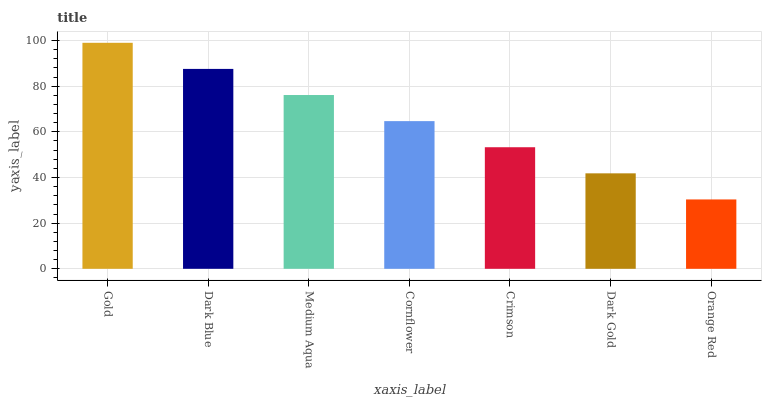Is Orange Red the minimum?
Answer yes or no. Yes. Is Gold the maximum?
Answer yes or no. Yes. Is Dark Blue the minimum?
Answer yes or no. No. Is Dark Blue the maximum?
Answer yes or no. No. Is Gold greater than Dark Blue?
Answer yes or no. Yes. Is Dark Blue less than Gold?
Answer yes or no. Yes. Is Dark Blue greater than Gold?
Answer yes or no. No. Is Gold less than Dark Blue?
Answer yes or no. No. Is Cornflower the high median?
Answer yes or no. Yes. Is Cornflower the low median?
Answer yes or no. Yes. Is Medium Aqua the high median?
Answer yes or no. No. Is Dark Blue the low median?
Answer yes or no. No. 